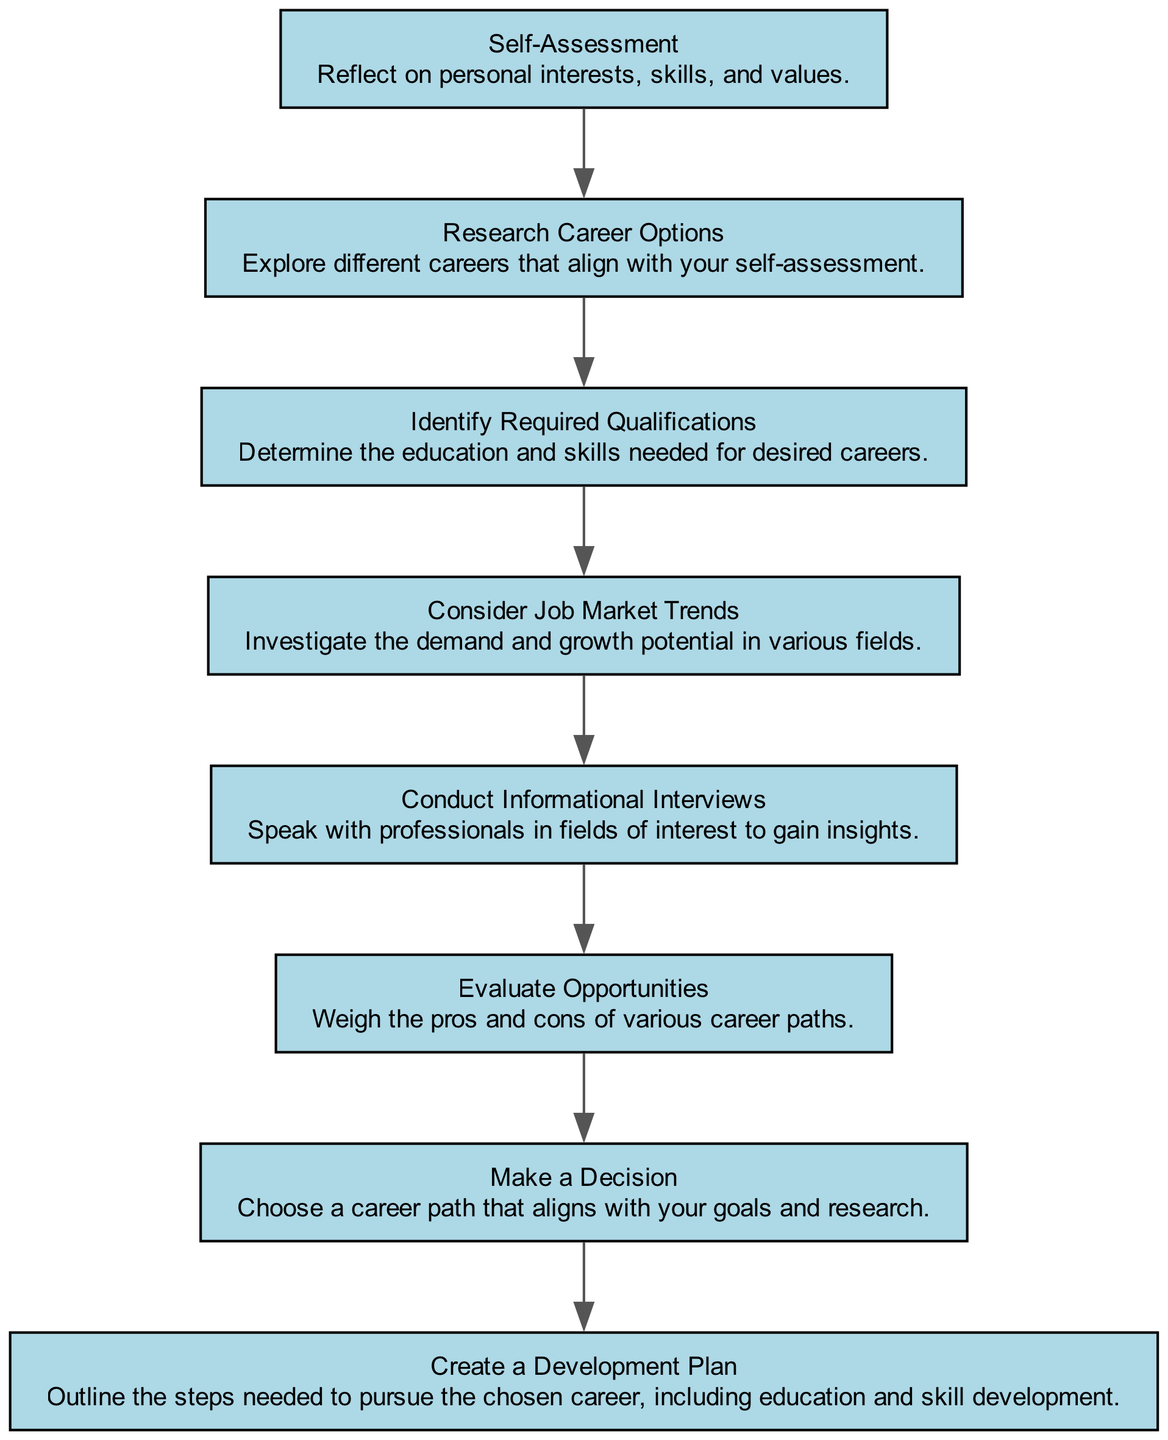What is the first step in the decision-making process? The first step listed in the diagram is "Self-Assessment," where individuals reflect on their personal interests, skills, and values.
Answer: Self-Assessment How many total steps are there in the diagram? The diagram lists a total of eight steps in the decision-making process for choosing a career path.
Answer: 8 What step comes after "Research Career Options"? After "Research Career Options," the next step in the flow is "Identify Required Qualifications."
Answer: Identify Required Qualifications What is the last step in the career decision-making process? The final step outlined in the diagram is "Create a Development Plan," where individuals outline the necessary steps to pursue their chosen career.
Answer: Create a Development Plan Which two steps are directly connected? "Consider Job Market Trends" is directly connected to "Conduct Informational Interviews," meaning they are adjacent steps in the flow of decision-making.
Answer: Consider Job Market Trends, Conduct Informational Interviews What kind of assessment is included as the first step? The first step involves a "Self-Assessment," which requires personal reflection on interests, skills, and values.
Answer: Self-Assessment Is there a step that focuses on engaging with professionals? Yes, the step "Conduct Informational Interviews" emphasizes the importance of speaking with professionals in fields of interest to gain insights.
Answer: Conduct Informational Interviews Which step evaluates various career paths? The step that evaluates different career paths is "Evaluate Opportunities," where you weigh the pros and cons of your options.
Answer: Evaluate Opportunities How does "Consider Job Market Trends" relate to career choice? This step investigates the demand and growth potential in various fields, which can influence the decision-making process regarding career paths.
Answer: Investigates demand and growth potential 